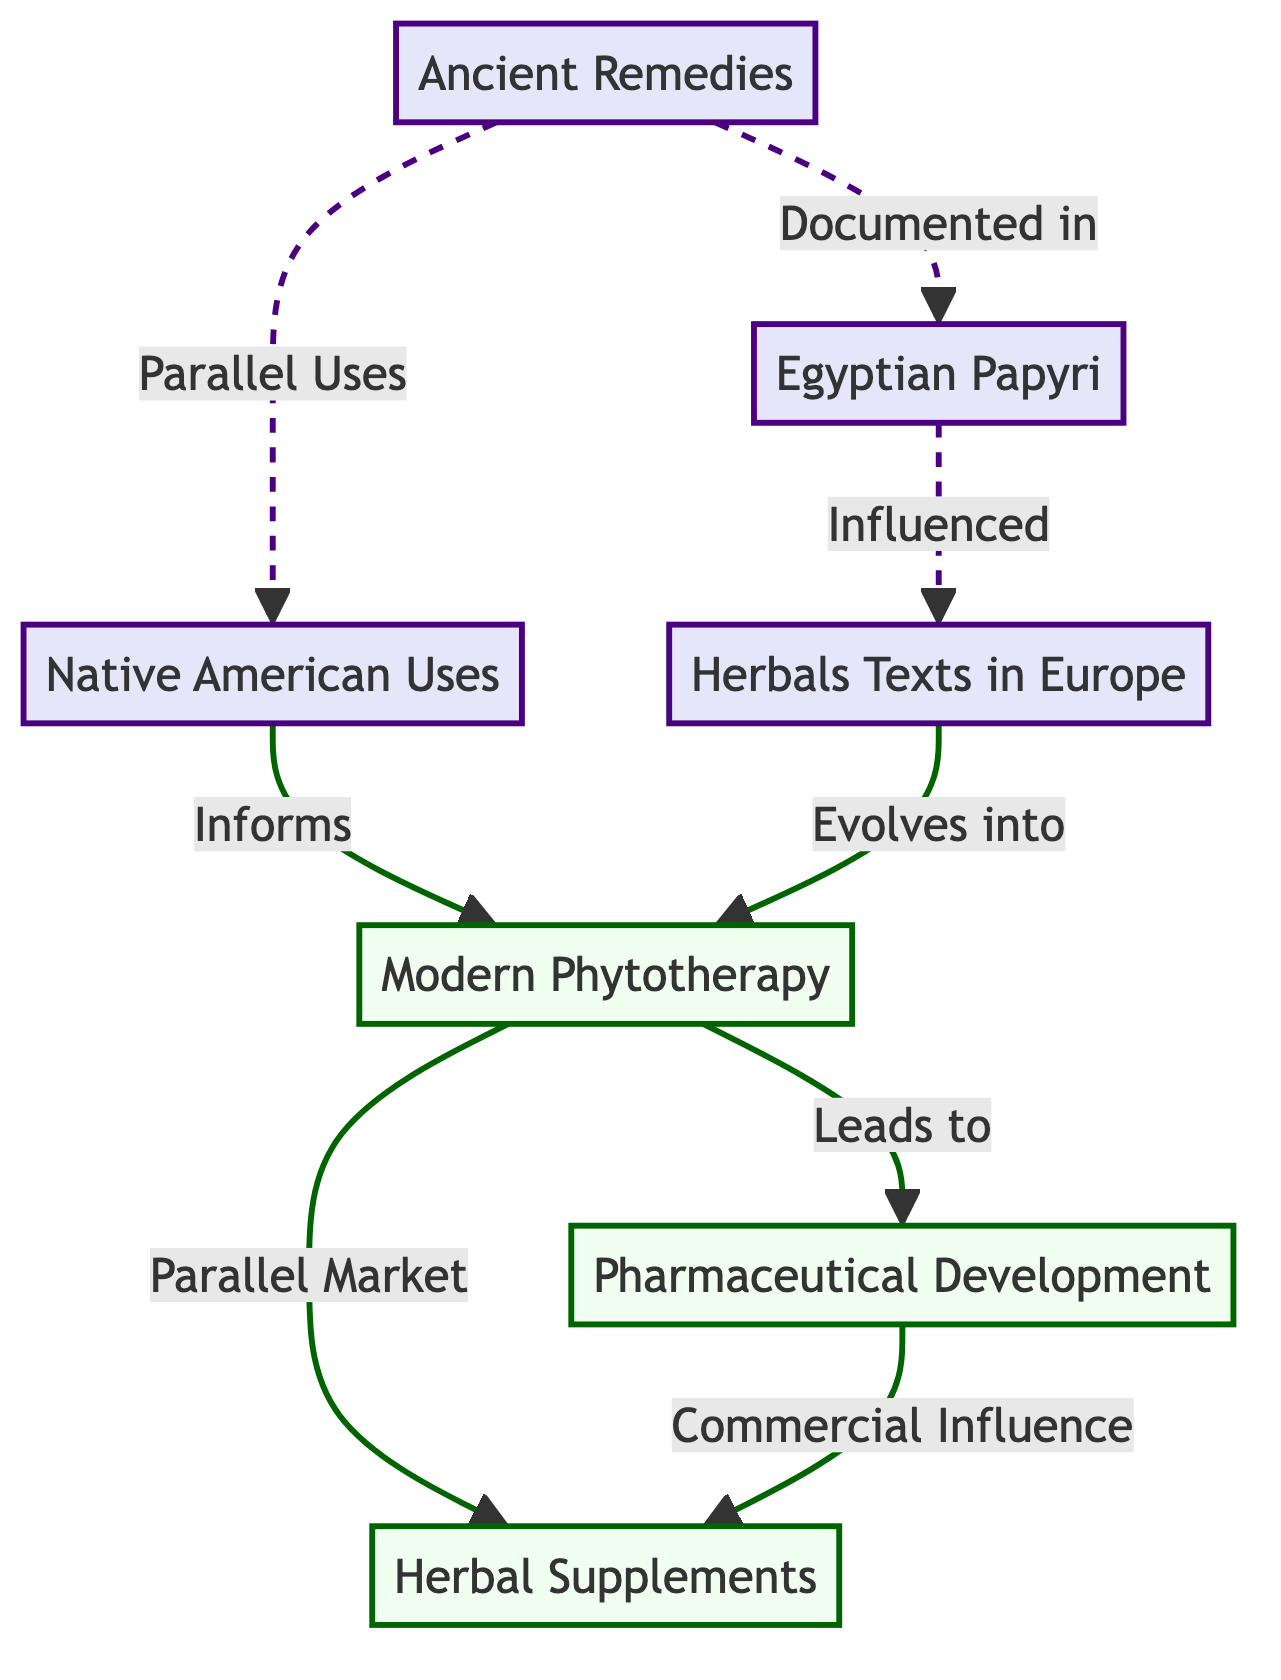What are the ancient remedies documented in? The diagram shows that ancient remedies are documented in Egyptian Papyri. This is a direct link from the node "Ancient Remedies" to the node "Egyptian Papyri."
Answer: Egyptian Papyri How many nodes are in the modern category? By counting the nodes within the modern category, which are "Modern Phytotherapy," "Pharmaceutical Development," and "Herbal Supplements," we find there are three distinct nodes.
Answer: 3 What influences herbals texts in Europe? The diagram indicates that Egyptian Papyri influenced herbals texts in Europe. This is shown by the directional arrow from "Egyptian Papyri" to "Herbals Texts in Europe."
Answer: Egyptian Papyri Which modern practice evolves from herbals texts? According to the diagram, modern phytotherapy evolves from herbals texts in Europe, as illustrated by the connection between these two nodes.
Answer: Modern Phytotherapy What leads from modern phytotherapy to pharmaceutical development? The arrow shows that modern phytotherapy leads to pharmaceutical development, indicating a direct relationship where modern phytotherapy serves as a foundation or influence for pharmaceutical development.
Answer: Pharmaceutical Development Which ancient practice parallels Native American uses? The diagram clearly illustrates that ancient remedies parallel Native American uses, indicating that both practices are related and reflect similar themes in their approaches.
Answer: Ancient Remedies Which category has a connection labeled 'Commercial Influence'? The link labeled 'Commercial Influence' points from pharmaceutical development to herbal supplements, showcasing the commercial impact of pharmaceutical practices on herbal product markets.
Answer: Herbal Supplements How does modern phytotherapy relate to herbal supplements? The diagram indicates that modern phytotherapy has a parallel market connection to herbal supplements, suggesting that both coexist in the contemporary market.
Answer: Parallel Market What informs modern phytotherapy? The connection from Native American uses to modern phytotherapy shows that traditional knowledge and practices have informed and shaped modern applications of medicinal plants.
Answer: Native American Uses 